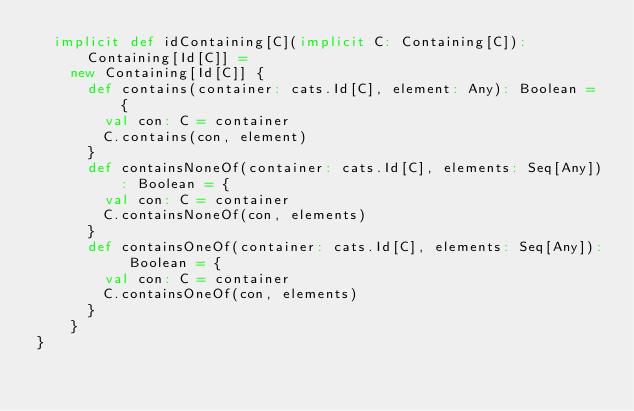Convert code to text. <code><loc_0><loc_0><loc_500><loc_500><_Scala_>  implicit def idContaining[C](implicit C: Containing[C]): Containing[Id[C]] =
    new Containing[Id[C]] {
      def contains(container: cats.Id[C], element: Any): Boolean = {
        val con: C = container
        C.contains(con, element)
      }
      def containsNoneOf(container: cats.Id[C], elements: Seq[Any]): Boolean = {
        val con: C = container
        C.containsNoneOf(con, elements)
      }
      def containsOneOf(container: cats.Id[C], elements: Seq[Any]): Boolean = {
        val con: C = container
        C.containsOneOf(con, elements)
      }
    }
}
</code> 